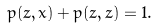<formula> <loc_0><loc_0><loc_500><loc_500>p ( z , x ) + p ( z , z ) = 1 .</formula> 